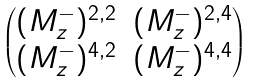<formula> <loc_0><loc_0><loc_500><loc_500>\begin{pmatrix} ( M _ { z } ^ { - } ) ^ { 2 , 2 } & ( M _ { z } ^ { - } ) ^ { 2 , 4 } \\ ( M _ { z } ^ { - } ) ^ { 4 , 2 } & ( M _ { z } ^ { - } ) ^ { 4 , 4 } \end{pmatrix}</formula> 